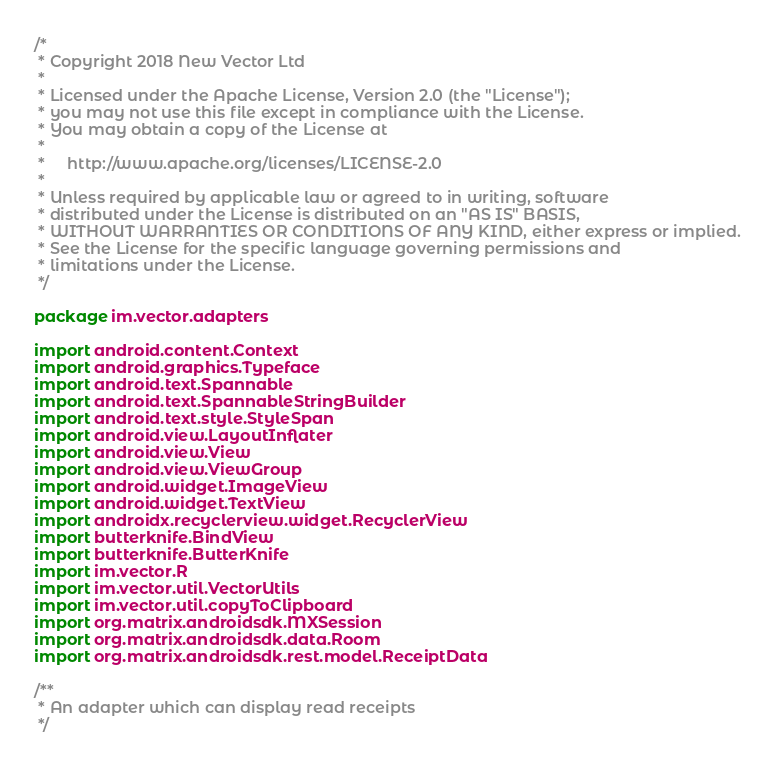Convert code to text. <code><loc_0><loc_0><loc_500><loc_500><_Kotlin_>/*
 * Copyright 2018 New Vector Ltd
 *
 * Licensed under the Apache License, Version 2.0 (the "License");
 * you may not use this file except in compliance with the License.
 * You may obtain a copy of the License at
 *
 *     http://www.apache.org/licenses/LICENSE-2.0
 *
 * Unless required by applicable law or agreed to in writing, software
 * distributed under the License is distributed on an "AS IS" BASIS,
 * WITHOUT WARRANTIES OR CONDITIONS OF ANY KIND, either express or implied.
 * See the License for the specific language governing permissions and
 * limitations under the License.
 */

package im.vector.adapters

import android.content.Context
import android.graphics.Typeface
import android.text.Spannable
import android.text.SpannableStringBuilder
import android.text.style.StyleSpan
import android.view.LayoutInflater
import android.view.View
import android.view.ViewGroup
import android.widget.ImageView
import android.widget.TextView
import androidx.recyclerview.widget.RecyclerView
import butterknife.BindView
import butterknife.ButterKnife
import im.vector.R
import im.vector.util.VectorUtils
import im.vector.util.copyToClipboard
import org.matrix.androidsdk.MXSession
import org.matrix.androidsdk.data.Room
import org.matrix.androidsdk.rest.model.ReceiptData

/**
 * An adapter which can display read receipts
 */</code> 